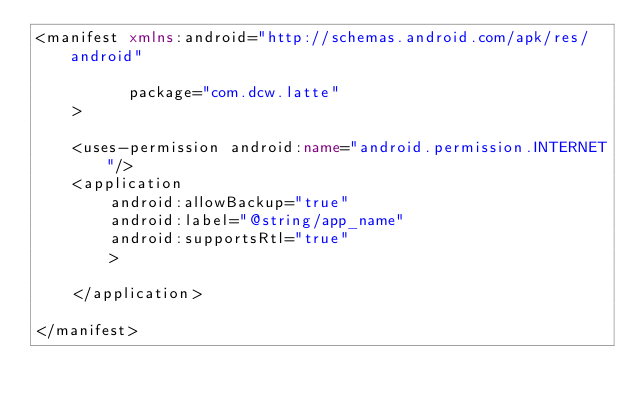<code> <loc_0><loc_0><loc_500><loc_500><_XML_><manifest xmlns:android="http://schemas.android.com/apk/res/android"

          package="com.dcw.latte"
    >

    <uses-permission android:name="android.permission.INTERNET"/>
    <application
        android:allowBackup="true"
        android:label="@string/app_name"
        android:supportsRtl="true"
        >

    </application>

</manifest>
</code> 